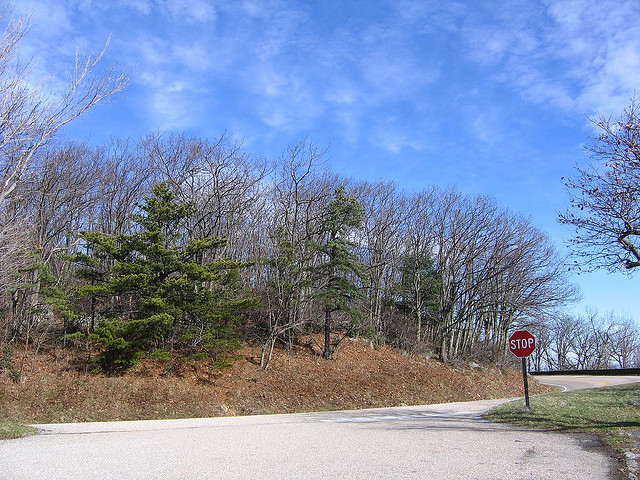What time of year does this photo seem to be taken? Given the bare deciduous trees and some with emerging leaves, it likely depicts early spring. 